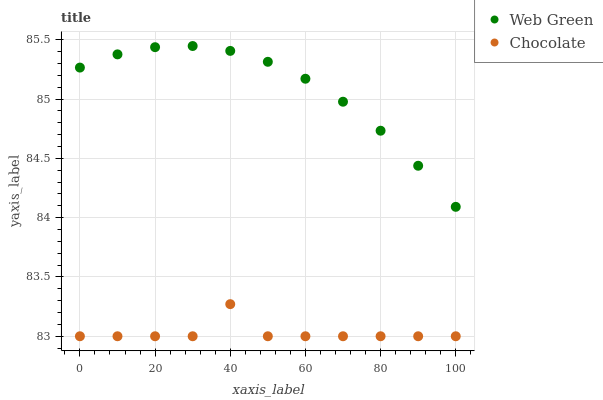Does Chocolate have the minimum area under the curve?
Answer yes or no. Yes. Does Web Green have the maximum area under the curve?
Answer yes or no. Yes. Does Chocolate have the maximum area under the curve?
Answer yes or no. No. Is Web Green the smoothest?
Answer yes or no. Yes. Is Chocolate the roughest?
Answer yes or no. Yes. Is Chocolate the smoothest?
Answer yes or no. No. Does Chocolate have the lowest value?
Answer yes or no. Yes. Does Web Green have the highest value?
Answer yes or no. Yes. Does Chocolate have the highest value?
Answer yes or no. No. Is Chocolate less than Web Green?
Answer yes or no. Yes. Is Web Green greater than Chocolate?
Answer yes or no. Yes. Does Chocolate intersect Web Green?
Answer yes or no. No. 